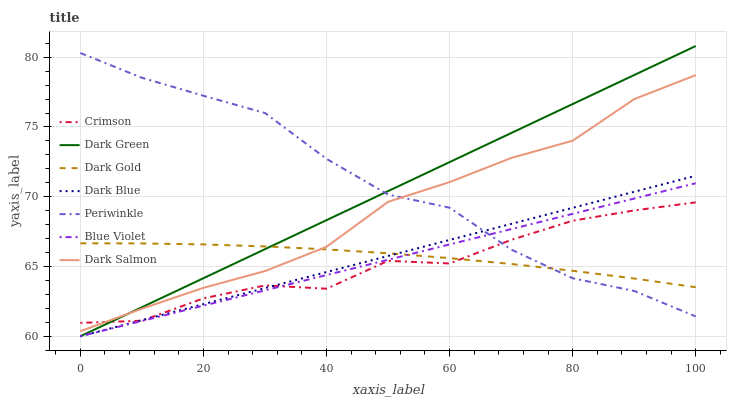Does Dark Salmon have the minimum area under the curve?
Answer yes or no. No. Does Dark Salmon have the maximum area under the curve?
Answer yes or no. No. Is Dark Salmon the smoothest?
Answer yes or no. No. Is Dark Salmon the roughest?
Answer yes or no. No. Does Dark Salmon have the lowest value?
Answer yes or no. No. Does Dark Salmon have the highest value?
Answer yes or no. No. Is Blue Violet less than Dark Salmon?
Answer yes or no. Yes. Is Dark Salmon greater than Dark Blue?
Answer yes or no. Yes. Does Blue Violet intersect Dark Salmon?
Answer yes or no. No. 